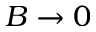Convert formula to latex. <formula><loc_0><loc_0><loc_500><loc_500>B \rightarrow 0</formula> 